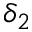Convert formula to latex. <formula><loc_0><loc_0><loc_500><loc_500>\delta _ { 2 }</formula> 